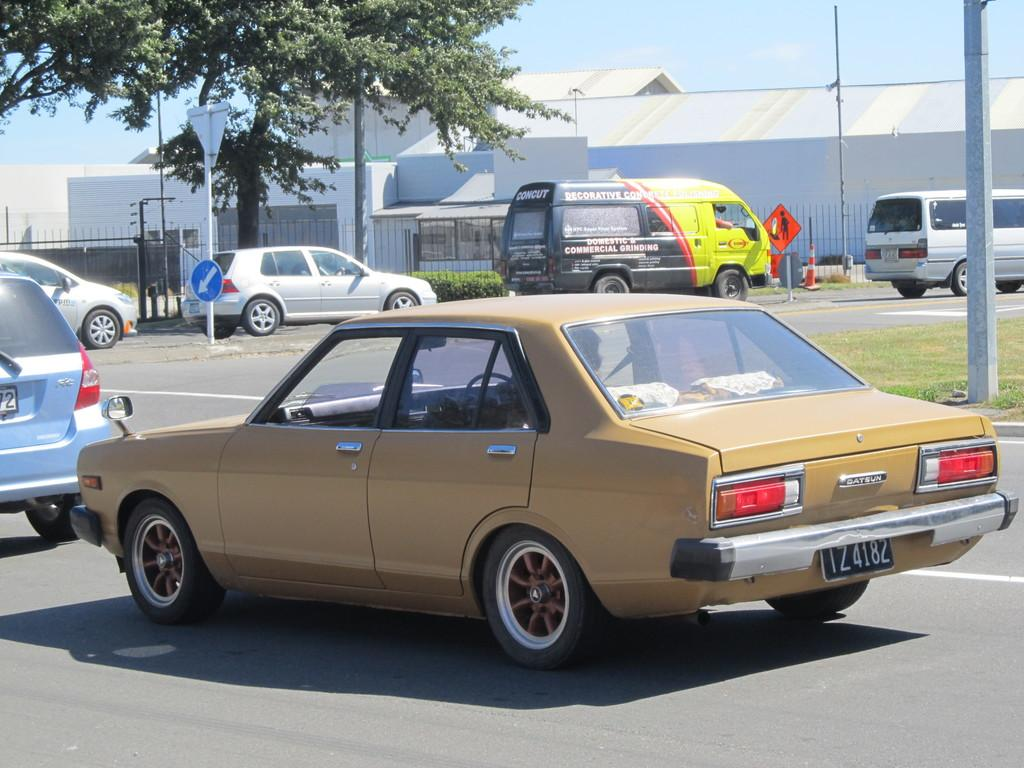What can be seen on the road in the image? There are vehicles on the road in the image. What type of informational or directional objects are present in the image? There are sign boards in the image. What type of vegetation is visible in the image? Grass and plants are visible in the image. What safety object is present in the image? A traffic cone is in the image. What type of vertical structures are present in the image? Poles are present in the image. What type of barriers are visible in the image? Fences are visible in the image. What type of small structures are in the image? Sheds are in the image. What type of large plant is in the image? A tree is in the image. What else can be seen in the image besides the mentioned objects? There are other objects in the image. What can be seen in the background of the image? The sky is visible in the background of the image. Where is the baby sitting in the image? There is no baby present in the image. What type of office furniture can be seen in the image? There is no office furniture or secretary present in the image. 